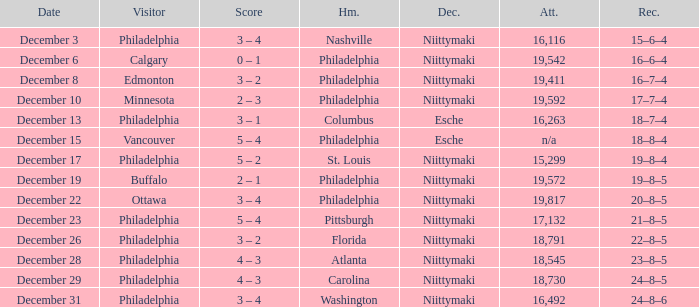What was the decision when the attendance was 19,592? Niittymaki. 